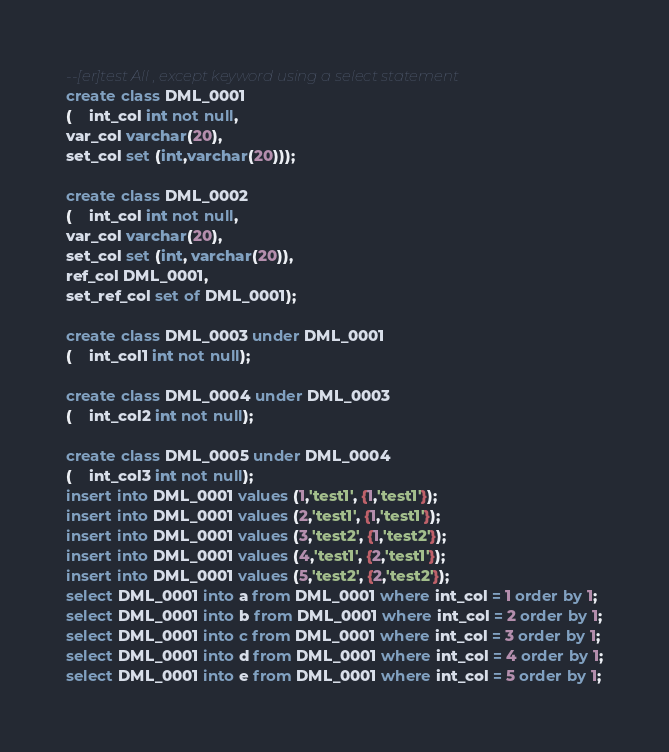Convert code to text. <code><loc_0><loc_0><loc_500><loc_500><_SQL_>--[er]test All , except keyword using a select statement
create class DML_0001
( 	int_col int not null,
var_col varchar(20),
set_col set (int,varchar(20)));

create class DML_0002
(	int_col int not null,
var_col varchar(20),
set_col set (int, varchar(20)),
ref_col DML_0001,
set_ref_col set of DML_0001);

create class DML_0003 under DML_0001
( 	int_col1 int not null);

create class DML_0004 under DML_0003
( 	int_col2 int not null);

create class DML_0005 under DML_0004
( 	int_col3 int not null);
insert into DML_0001 values (1,'test1', {1,'test1'});
insert into DML_0001 values (2,'test1', {1,'test1'});
insert into DML_0001 values (3,'test2', {1,'test2'});
insert into DML_0001 values (4,'test1', {2,'test1'});
insert into DML_0001 values (5,'test2', {2,'test2'});
select DML_0001 into a from DML_0001 where int_col = 1 order by 1;
select DML_0001 into b from DML_0001 where int_col = 2 order by 1;
select DML_0001 into c from DML_0001 where int_col = 3 order by 1;
select DML_0001 into d from DML_0001 where int_col = 4 order by 1;
select DML_0001 into e from DML_0001 where int_col = 5 order by 1;</code> 